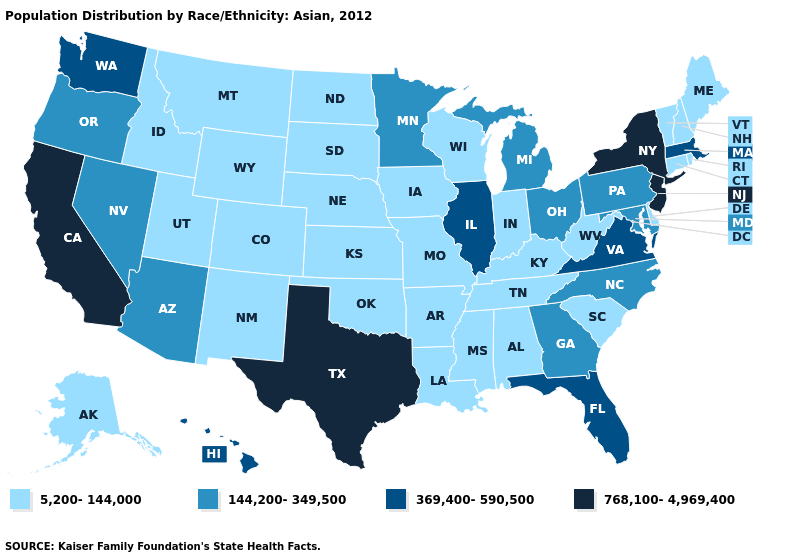What is the value of Arkansas?
Concise answer only. 5,200-144,000. Which states have the lowest value in the MidWest?
Write a very short answer. Indiana, Iowa, Kansas, Missouri, Nebraska, North Dakota, South Dakota, Wisconsin. What is the value of Rhode Island?
Give a very brief answer. 5,200-144,000. Does Hawaii have the lowest value in the West?
Be succinct. No. Does Maryland have the same value as South Dakota?
Be succinct. No. Which states have the highest value in the USA?
Concise answer only. California, New Jersey, New York, Texas. What is the lowest value in the USA?
Concise answer only. 5,200-144,000. Among the states that border Texas , which have the highest value?
Be succinct. Arkansas, Louisiana, New Mexico, Oklahoma. Does the first symbol in the legend represent the smallest category?
Answer briefly. Yes. Name the states that have a value in the range 5,200-144,000?
Keep it brief. Alabama, Alaska, Arkansas, Colorado, Connecticut, Delaware, Idaho, Indiana, Iowa, Kansas, Kentucky, Louisiana, Maine, Mississippi, Missouri, Montana, Nebraska, New Hampshire, New Mexico, North Dakota, Oklahoma, Rhode Island, South Carolina, South Dakota, Tennessee, Utah, Vermont, West Virginia, Wisconsin, Wyoming. What is the highest value in the South ?
Write a very short answer. 768,100-4,969,400. Does Louisiana have a lower value than Kansas?
Give a very brief answer. No. Does Texas have the highest value in the South?
Give a very brief answer. Yes. Does the first symbol in the legend represent the smallest category?
Answer briefly. Yes. What is the value of California?
Answer briefly. 768,100-4,969,400. 